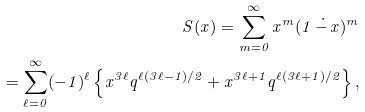<formula> <loc_0><loc_0><loc_500><loc_500>S ( x ) = \sum ^ { \infty } _ { m = 0 } x ^ { m } ( 1 \, \dot { - } \, x ) ^ { m } \\ = \sum ^ { \infty } _ { \ell = 0 } ( - 1 ) ^ { \ell } \left \{ x ^ { 3 \ell } q ^ { \ell ( 3 \ell - 1 ) / 2 } + x ^ { 3 \ell + 1 } q ^ { \ell ( 3 \ell + 1 ) / 2 } \right \} ,</formula> 